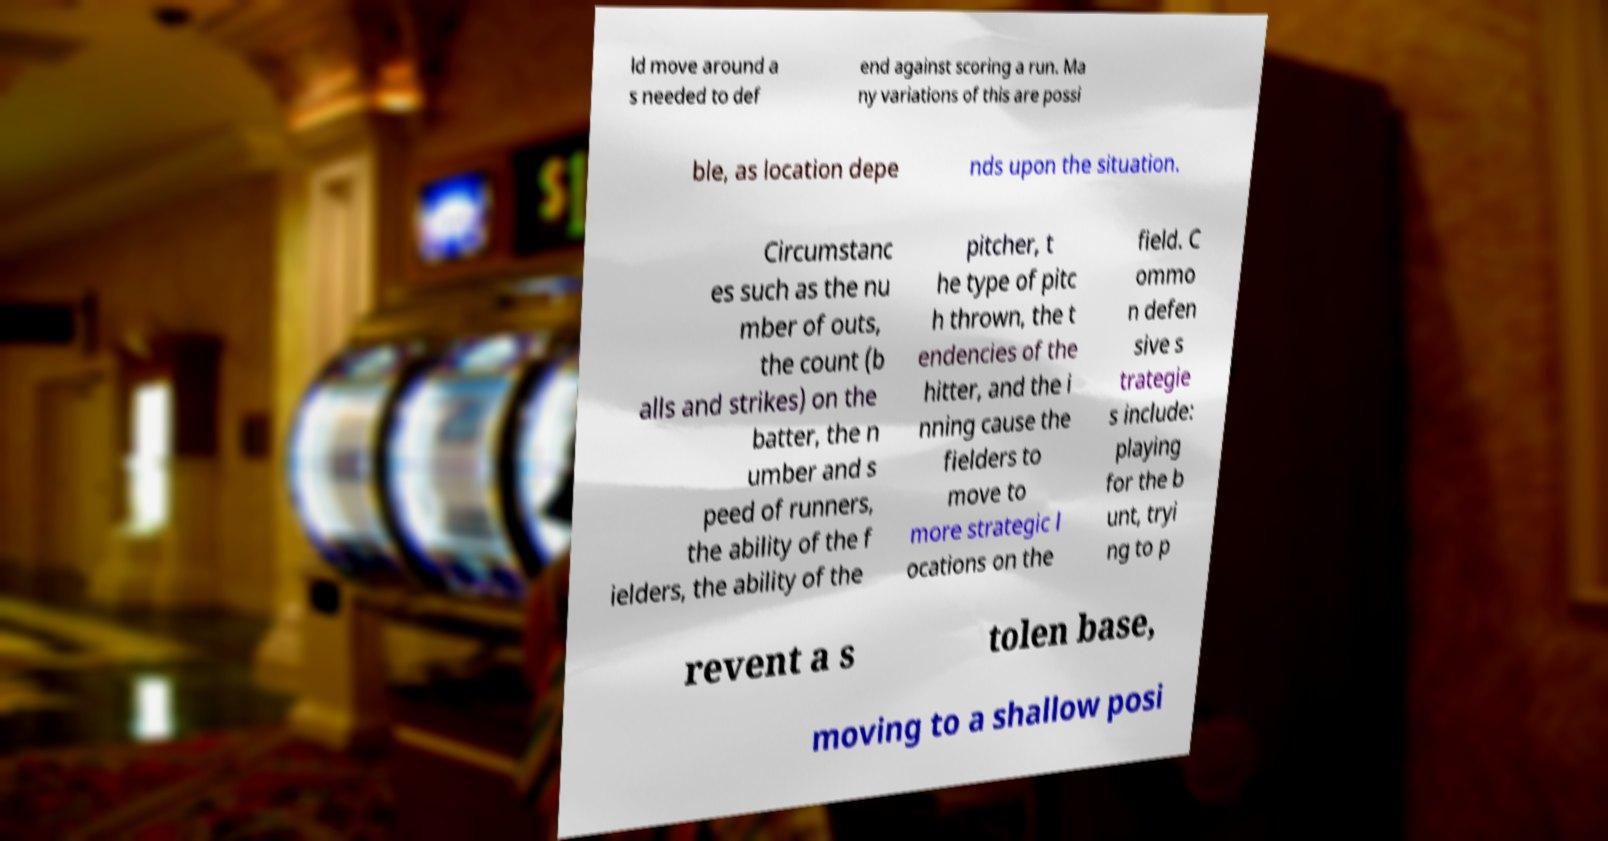I need the written content from this picture converted into text. Can you do that? ld move around a s needed to def end against scoring a run. Ma ny variations of this are possi ble, as location depe nds upon the situation. Circumstanc es such as the nu mber of outs, the count (b alls and strikes) on the batter, the n umber and s peed of runners, the ability of the f ielders, the ability of the pitcher, t he type of pitc h thrown, the t endencies of the hitter, and the i nning cause the fielders to move to more strategic l ocations on the field. C ommo n defen sive s trategie s include: playing for the b unt, tryi ng to p revent a s tolen base, moving to a shallow posi 